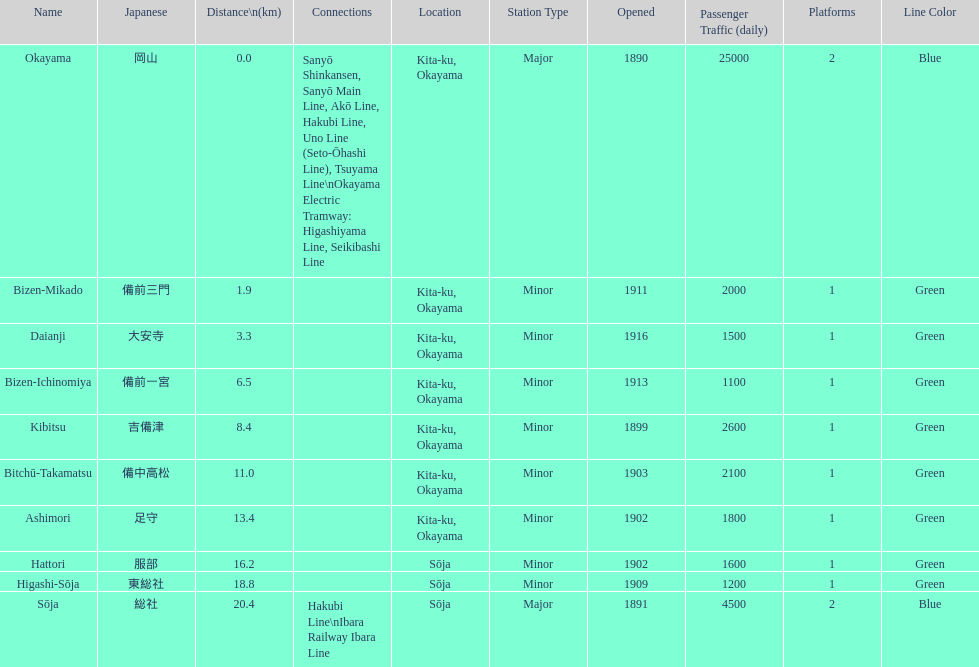How many station are located in kita-ku, okayama? 7. 